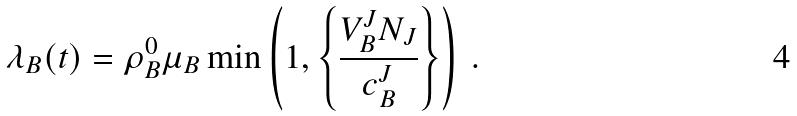Convert formula to latex. <formula><loc_0><loc_0><loc_500><loc_500>\lambda _ { B } ( t ) = \rho _ { B } ^ { 0 } \mu _ { B } \min \left ( 1 , \left \{ \frac { V _ { B } ^ { J } N _ { J } } { c _ { B } ^ { J } } \right \} \right ) \, .</formula> 